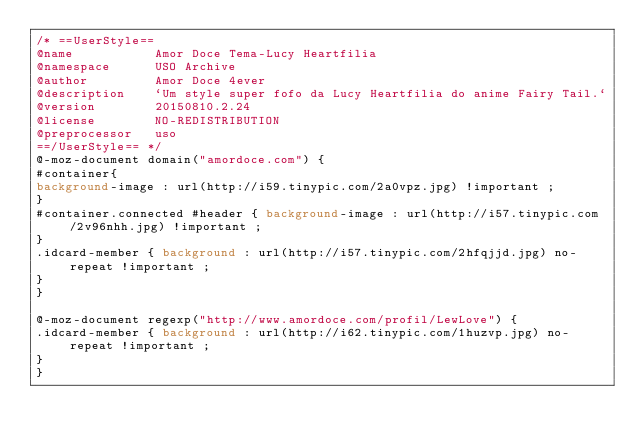<code> <loc_0><loc_0><loc_500><loc_500><_CSS_>/* ==UserStyle==
@name           Amor Doce Tema-Lucy Heartfilia
@namespace      USO Archive
@author         Amor Doce 4ever
@description    `Um style super fofo da Lucy Heartfilia do anime Fairy Tail.`
@version        20150810.2.24
@license        NO-REDISTRIBUTION
@preprocessor   uso
==/UserStyle== */
@-moz-document domain("amordoce.com") {
#container{
background-image : url(http://i59.tinypic.com/2a0vpz.jpg) !important ;
}
#container.connected #header { background-image : url(http://i57.tinypic.com/2v96nhh.jpg) !important ;
}
.idcard-member { background : url(http://i57.tinypic.com/2hfqjjd.jpg) no-repeat !important ;
}
}

@-moz-document regexp("http://www.amordoce.com/profil/LewLove") {
.idcard-member { background : url(http://i62.tinypic.com/1huzvp.jpg) no-repeat !important ;
}
}</code> 